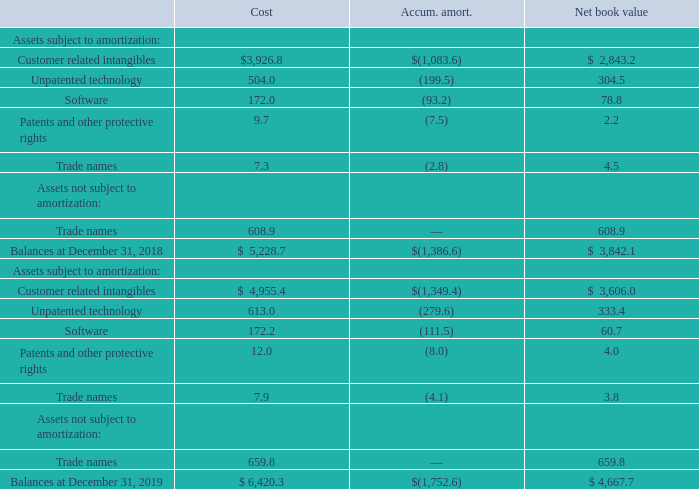Other intangible assets were comprised of:
Amortization expense of other intangible assets was $364.7, $316.5, and $294.3 during the years ended December 31, 2019, 2018 and 2017, respectively. Amortization expense is expected to be $400 in 2020, $383 in 2021, $379 in 2022, $347 in 2023 and $321 in 2024.
What are the expected amortization expenses in 2020 and 2021, respectively? $400, $383. What is the total net book value of other intangible assets as at December 31, 2019? $ 4,667.7. What are the accumulated amortizations in 2018 and 2019, respectively? $(1,386.6), $(1,752.6). What is the percentage change in balances of net book value from 2018 to 2019?
Answer scale should be: percent. (4,667.7-3,842.1)/3,842.1 
Answer: 21.49. What is the proportion of the cost of software and trade names over total cost in 2018? (172.0+7.3)/5,228.7 
Answer: 0.03. What is the percentage change in the cost of customer-related intangible assets in 2019 compared to 2018?
Answer scale should be: percent. (4,955.4-3,926.8)/3,926.8 
Answer: 26.19. 